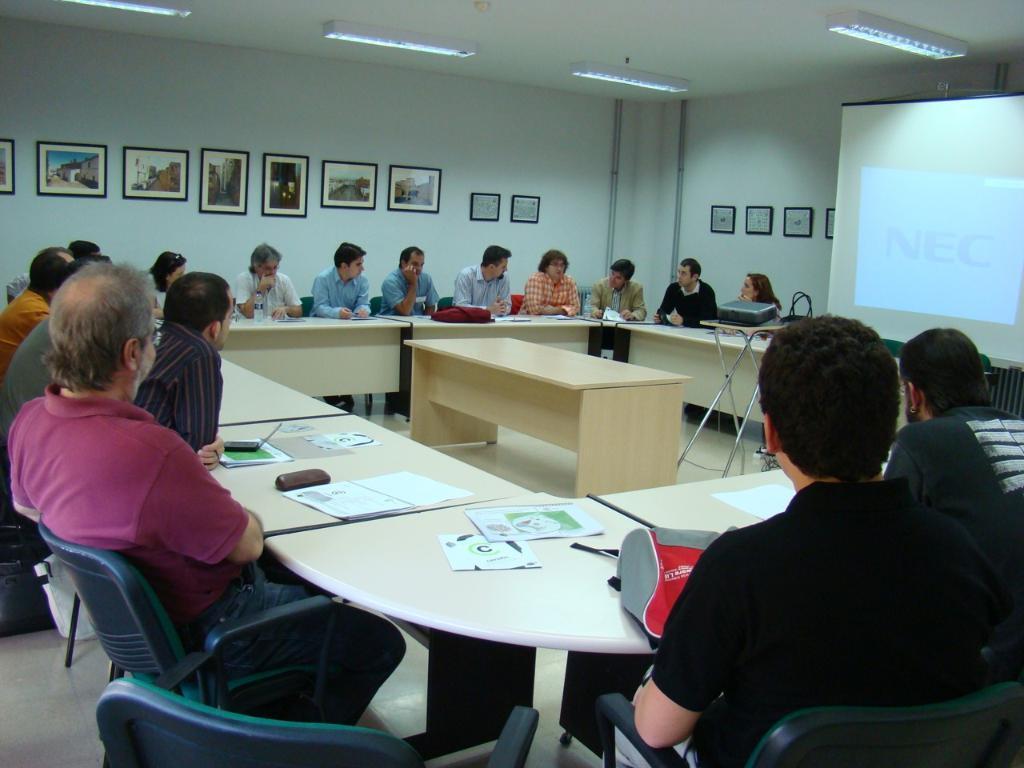Describe this image in one or two sentences. In the picture we can see a set of people sitting on the chairs near the tables, in the background we can see a wall with photo frames and lights. 